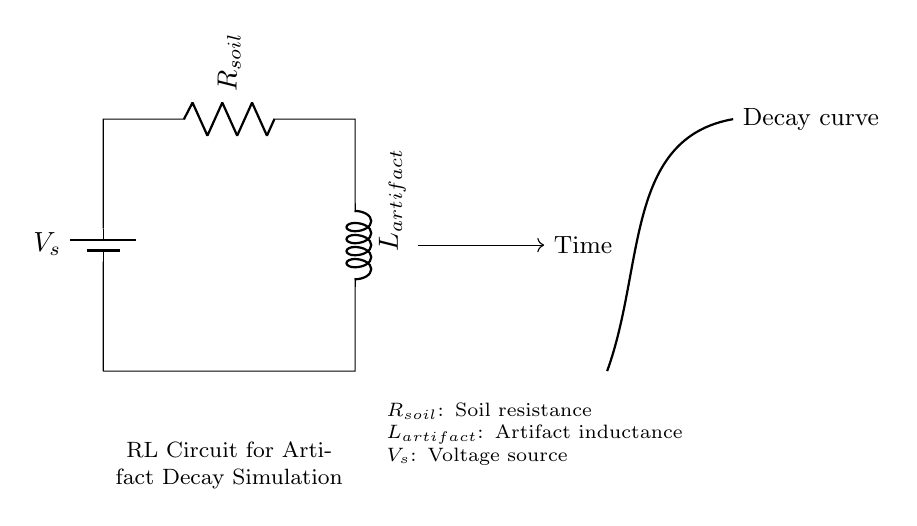What components are in this circuit? The circuit contains a voltage source (V_s), a resistor (R_soil), and an inductor (L_artifact). Each of these components is labeled within the circuit diagram.
Answer: Voltage source, resistor, inductor What does \( R_{soil} \) represent? \( R_{soil} \) symbolizes the resistance of the soil, indicating how it impacts the decay of the metal artifact. It is labeled directly in the circuit diagram.
Answer: Soil resistance What does \( L_{artifact} \) describe in this circuit? \( L_{artifact} \) indicates the inductance related to the metal artifact, reflecting how the artifact's properties influence the circuit's behavior over time. It is also labeled in the circuit diagram.
Answer: Artifact inductance What type of circuit is this? This is an RL circuit, which contains a resistor and an inductor in series. The combination of these components allows for analysis of the transient response, such as decay patterns.
Answer: RL circuit How does the voltage source affect the circuit? The voltage source \( V_s \) provides the necessary potential that drives current through the circuit. This is fundamental for initiating the decay simulation of the artifact over time.
Answer: Drives current What is represented by the decay curve in the diagram? The decay curve visualizes how the induced voltage or current in the circuit changes over time, simulating the gradual decay of the metal artifact in varying soil conditions.
Answer: Decay simulation How do the resistor and inductor interact in this circuit? The resistor determines how quickly the current decays over time due to resistance, while the inductor stores energy and contributes to the overall decay process. Their interaction leads to a characteristic time constant that influences the decay behavior.
Answer: Time constant interaction 